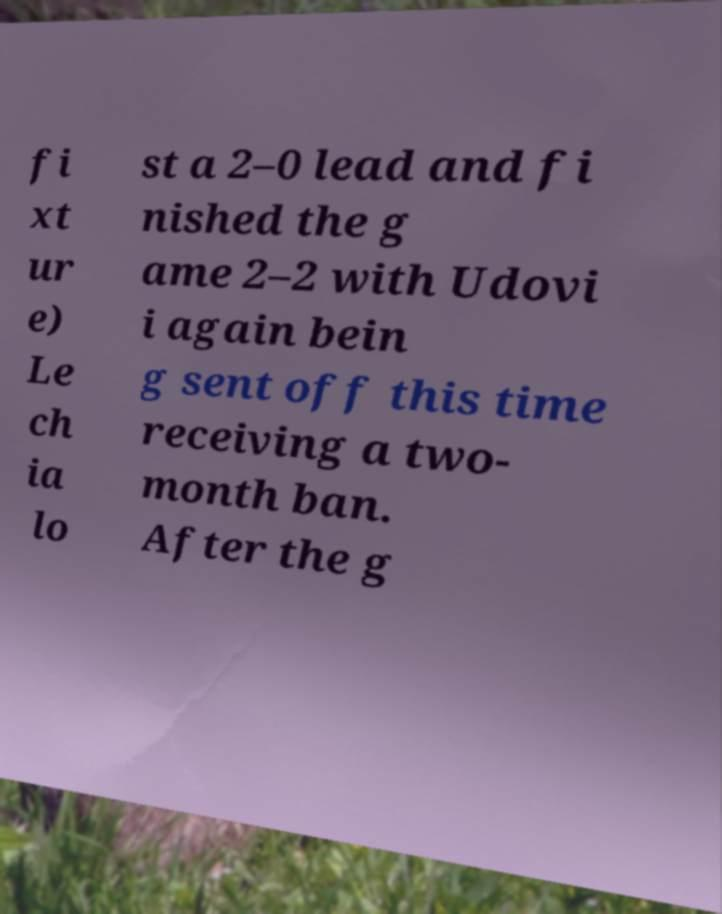There's text embedded in this image that I need extracted. Can you transcribe it verbatim? fi xt ur e) Le ch ia lo st a 2–0 lead and fi nished the g ame 2–2 with Udovi i again bein g sent off this time receiving a two- month ban. After the g 